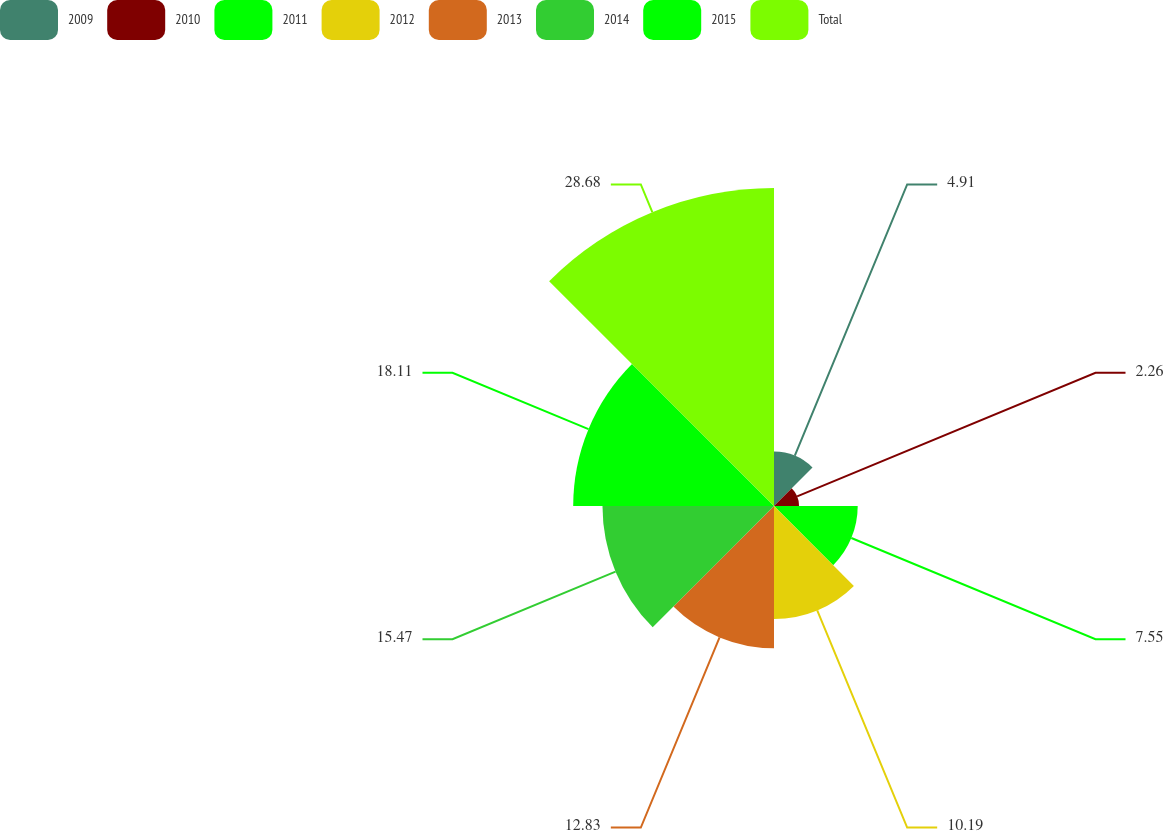Convert chart to OTSL. <chart><loc_0><loc_0><loc_500><loc_500><pie_chart><fcel>2009<fcel>2010<fcel>2011<fcel>2012<fcel>2013<fcel>2014<fcel>2015<fcel>Total<nl><fcel>4.91%<fcel>2.26%<fcel>7.55%<fcel>10.19%<fcel>12.83%<fcel>15.47%<fcel>18.11%<fcel>28.68%<nl></chart> 